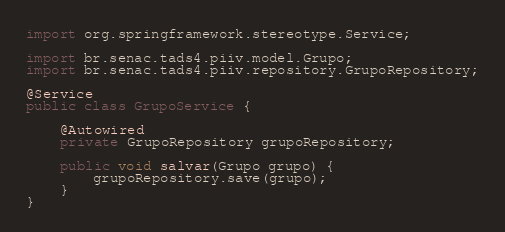<code> <loc_0><loc_0><loc_500><loc_500><_Java_>import org.springframework.stereotype.Service;

import br.senac.tads4.piiv.model.Grupo;
import br.senac.tads4.piiv.repository.GrupoRepository;

@Service
public class GrupoService {

	@Autowired
	private GrupoRepository grupoRepository;

	public void salvar(Grupo grupo) {
		grupoRepository.save(grupo);
	}
}
</code> 